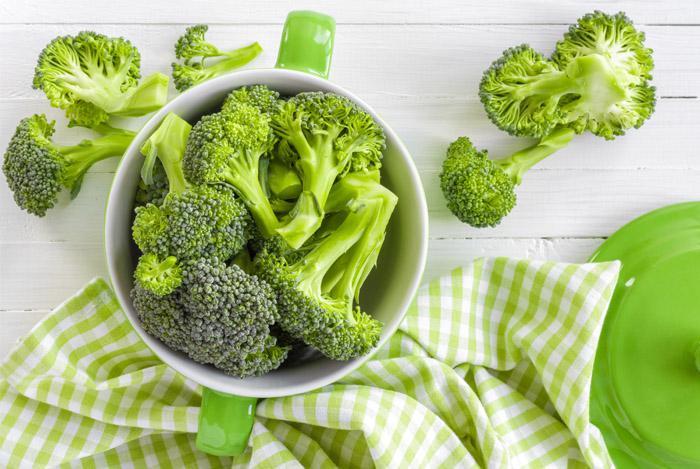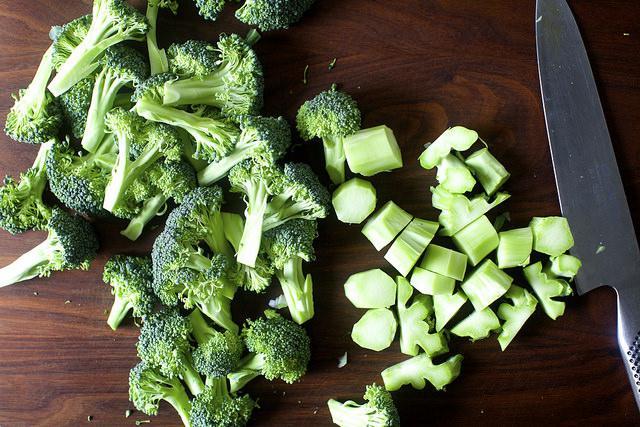The first image is the image on the left, the second image is the image on the right. Analyze the images presented: Is the assertion "In at least one image there is a total of one full head of lettuce." valid? Answer yes or no. No. 